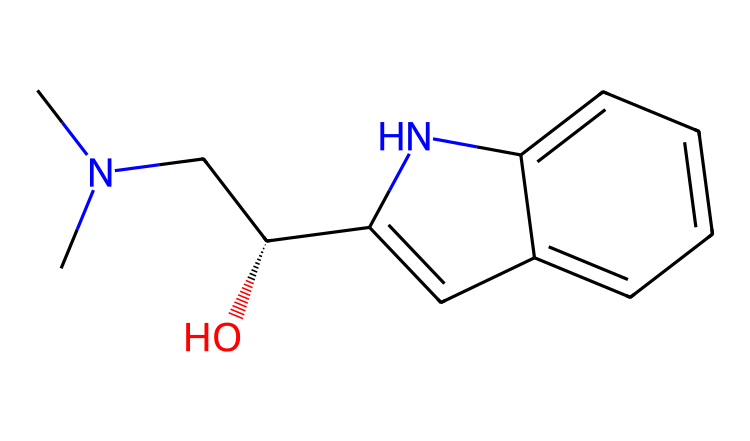What is the main functional group present in this chemical? The structure contains a hydroxyl group (-OH) indicated by the "O" atom bonded to a carbon. This is a key identifying feature of alcohols.
Answer: hydroxyl group How many rings are present in the structure? By examining the structure, two distinct cyclic systems can be identified, confirming that there are indeed two rings present in the compound.
Answer: two What type of compound is this? The presence of a nitrogen atom within a cyclic structure suggests that this is an alkaloid, which is a category characterized by their nitrogen-containing compounds and pharmacological effects.
Answer: alkaloid Does this chemical contain any stereocenters? Looking for carbon atoms with four different substituents shows that there is one carbons in the molecule clearly indicated to have stereochemistry by the "C@" notation, confirming the presence of chirality.
Answer: yes What is the total number of carbon atoms in this chemical? Counting all "C" atoms in the given SMILES notation leads us to a total of 12 carbon atoms present within the structure.
Answer: twelve Which atom in the structure is capable of forming hydrogen bonds? The oxygen atom is connected to a hydrogen atom in the hydroxyl group, making it able to form hydrogen bonds due to its electronegativity and presence of available lone pairs.
Answer: oxygen 